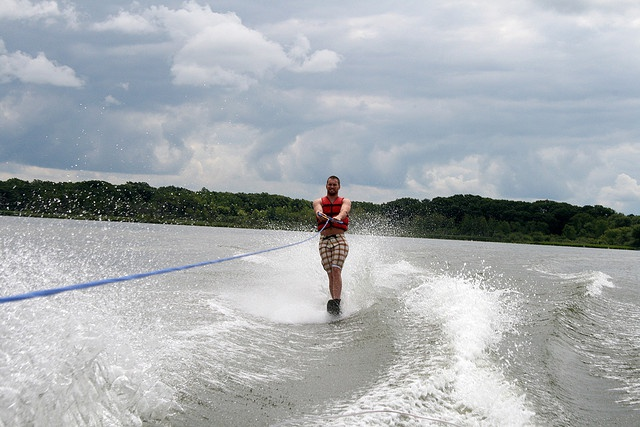Describe the objects in this image and their specific colors. I can see people in lightgray, maroon, black, and gray tones in this image. 